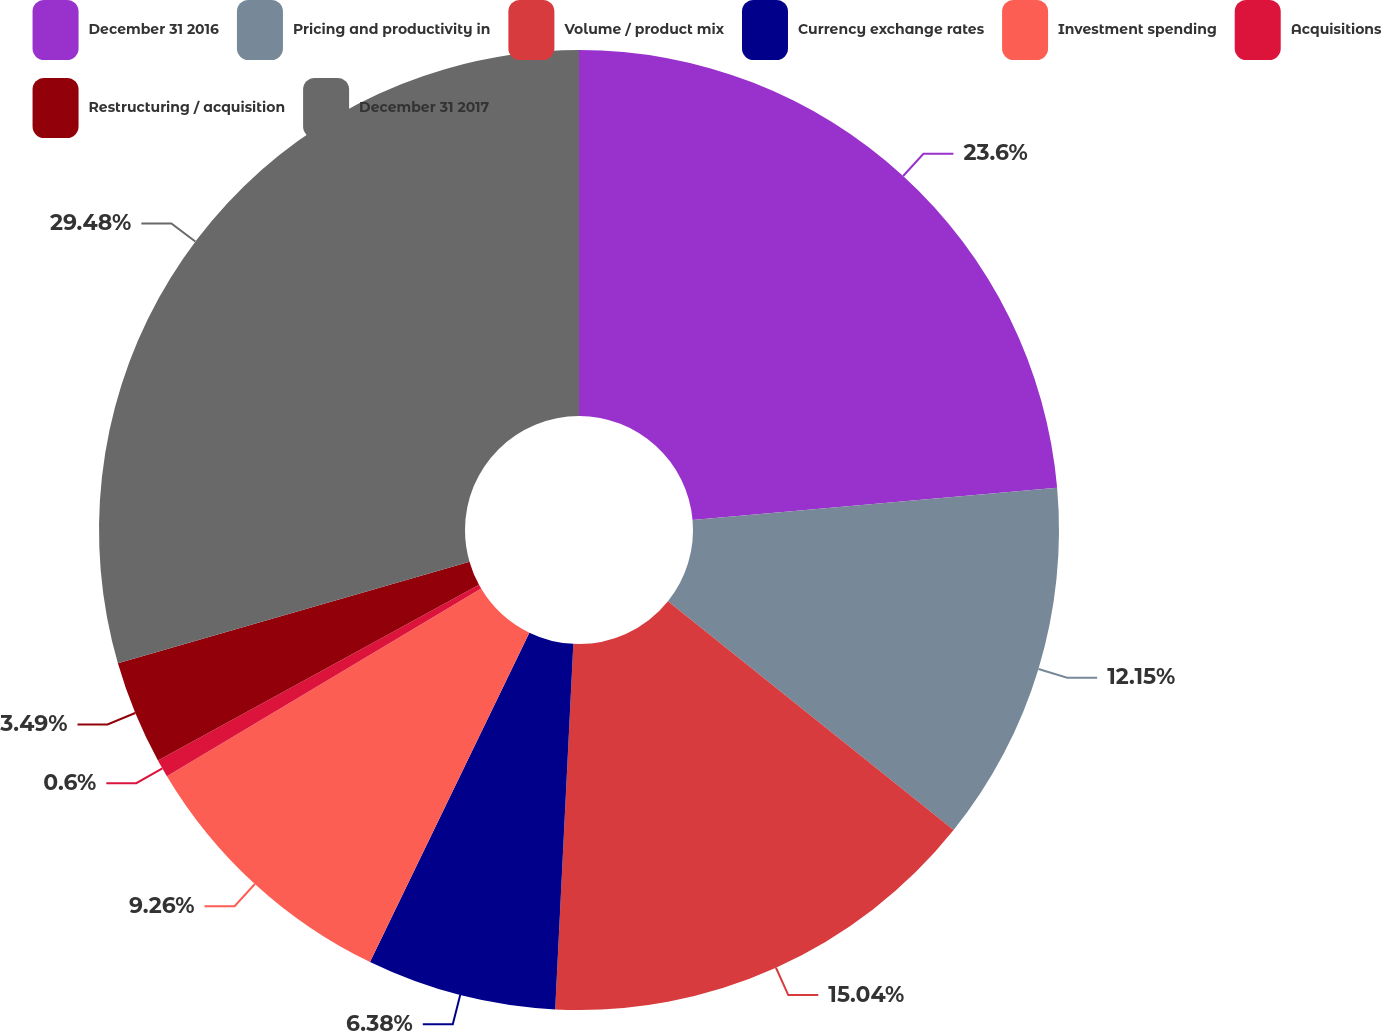Convert chart. <chart><loc_0><loc_0><loc_500><loc_500><pie_chart><fcel>December 31 2016<fcel>Pricing and productivity in<fcel>Volume / product mix<fcel>Currency exchange rates<fcel>Investment spending<fcel>Acquisitions<fcel>Restructuring / acquisition<fcel>December 31 2017<nl><fcel>23.6%<fcel>12.15%<fcel>15.04%<fcel>6.38%<fcel>9.26%<fcel>0.6%<fcel>3.49%<fcel>29.48%<nl></chart> 